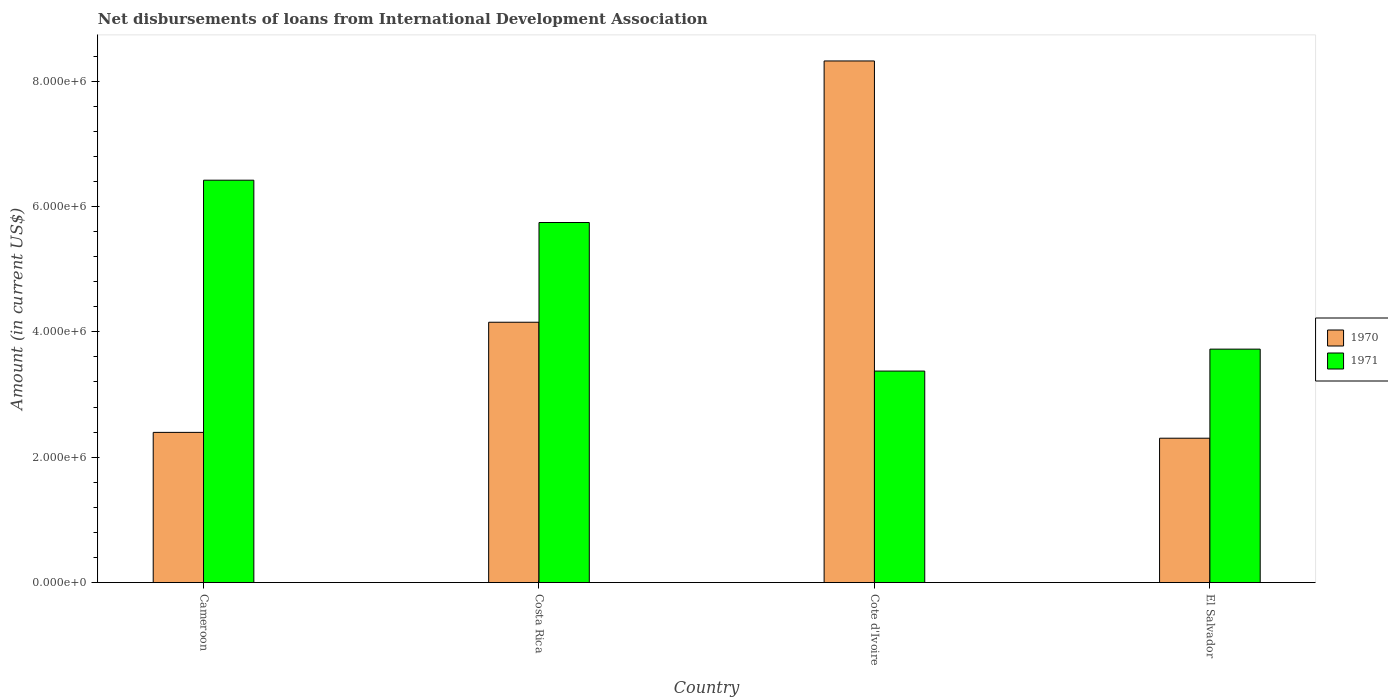How many different coloured bars are there?
Offer a very short reply. 2. How many groups of bars are there?
Provide a short and direct response. 4. Are the number of bars on each tick of the X-axis equal?
Provide a short and direct response. Yes. How many bars are there on the 4th tick from the left?
Your response must be concise. 2. What is the label of the 1st group of bars from the left?
Provide a short and direct response. Cameroon. What is the amount of loans disbursed in 1970 in Cote d'Ivoire?
Your answer should be very brief. 8.32e+06. Across all countries, what is the maximum amount of loans disbursed in 1970?
Offer a terse response. 8.32e+06. Across all countries, what is the minimum amount of loans disbursed in 1971?
Offer a very short reply. 3.37e+06. In which country was the amount of loans disbursed in 1970 maximum?
Provide a short and direct response. Cote d'Ivoire. In which country was the amount of loans disbursed in 1970 minimum?
Your response must be concise. El Salvador. What is the total amount of loans disbursed in 1970 in the graph?
Keep it short and to the point. 1.72e+07. What is the difference between the amount of loans disbursed in 1970 in Costa Rica and that in El Salvador?
Make the answer very short. 1.85e+06. What is the difference between the amount of loans disbursed in 1971 in El Salvador and the amount of loans disbursed in 1970 in Cameroon?
Your answer should be compact. 1.33e+06. What is the average amount of loans disbursed in 1971 per country?
Provide a short and direct response. 4.82e+06. What is the difference between the amount of loans disbursed of/in 1971 and amount of loans disbursed of/in 1970 in Cameroon?
Ensure brevity in your answer.  4.02e+06. In how many countries, is the amount of loans disbursed in 1970 greater than 4000000 US$?
Your answer should be very brief. 2. What is the ratio of the amount of loans disbursed in 1971 in Cameroon to that in El Salvador?
Provide a succinct answer. 1.72. Is the difference between the amount of loans disbursed in 1971 in Cameroon and El Salvador greater than the difference between the amount of loans disbursed in 1970 in Cameroon and El Salvador?
Ensure brevity in your answer.  Yes. What is the difference between the highest and the second highest amount of loans disbursed in 1971?
Your response must be concise. 2.70e+06. What is the difference between the highest and the lowest amount of loans disbursed in 1971?
Offer a very short reply. 3.04e+06. In how many countries, is the amount of loans disbursed in 1970 greater than the average amount of loans disbursed in 1970 taken over all countries?
Provide a succinct answer. 1. What does the 2nd bar from the left in Costa Rica represents?
Give a very brief answer. 1971. How many countries are there in the graph?
Keep it short and to the point. 4. What is the difference between two consecutive major ticks on the Y-axis?
Provide a short and direct response. 2.00e+06. Does the graph contain any zero values?
Offer a terse response. No. Does the graph contain grids?
Your answer should be compact. No. Where does the legend appear in the graph?
Keep it short and to the point. Center right. How many legend labels are there?
Give a very brief answer. 2. What is the title of the graph?
Make the answer very short. Net disbursements of loans from International Development Association. Does "1962" appear as one of the legend labels in the graph?
Provide a succinct answer. No. What is the label or title of the X-axis?
Your response must be concise. Country. What is the Amount (in current US$) in 1970 in Cameroon?
Provide a succinct answer. 2.40e+06. What is the Amount (in current US$) in 1971 in Cameroon?
Offer a very short reply. 6.42e+06. What is the Amount (in current US$) of 1970 in Costa Rica?
Offer a terse response. 4.15e+06. What is the Amount (in current US$) in 1971 in Costa Rica?
Offer a very short reply. 5.74e+06. What is the Amount (in current US$) in 1970 in Cote d'Ivoire?
Give a very brief answer. 8.32e+06. What is the Amount (in current US$) in 1971 in Cote d'Ivoire?
Ensure brevity in your answer.  3.37e+06. What is the Amount (in current US$) of 1970 in El Salvador?
Offer a terse response. 2.30e+06. What is the Amount (in current US$) of 1971 in El Salvador?
Offer a very short reply. 3.72e+06. Across all countries, what is the maximum Amount (in current US$) of 1970?
Offer a very short reply. 8.32e+06. Across all countries, what is the maximum Amount (in current US$) of 1971?
Your answer should be very brief. 6.42e+06. Across all countries, what is the minimum Amount (in current US$) in 1970?
Your answer should be very brief. 2.30e+06. Across all countries, what is the minimum Amount (in current US$) of 1971?
Make the answer very short. 3.37e+06. What is the total Amount (in current US$) in 1970 in the graph?
Make the answer very short. 1.72e+07. What is the total Amount (in current US$) of 1971 in the graph?
Provide a succinct answer. 1.93e+07. What is the difference between the Amount (in current US$) of 1970 in Cameroon and that in Costa Rica?
Provide a succinct answer. -1.76e+06. What is the difference between the Amount (in current US$) of 1971 in Cameroon and that in Costa Rica?
Give a very brief answer. 6.75e+05. What is the difference between the Amount (in current US$) of 1970 in Cameroon and that in Cote d'Ivoire?
Your response must be concise. -5.92e+06. What is the difference between the Amount (in current US$) in 1971 in Cameroon and that in Cote d'Ivoire?
Your answer should be very brief. 3.04e+06. What is the difference between the Amount (in current US$) of 1970 in Cameroon and that in El Salvador?
Make the answer very short. 9.30e+04. What is the difference between the Amount (in current US$) of 1971 in Cameroon and that in El Salvador?
Offer a very short reply. 2.70e+06. What is the difference between the Amount (in current US$) of 1970 in Costa Rica and that in Cote d'Ivoire?
Your answer should be compact. -4.17e+06. What is the difference between the Amount (in current US$) in 1971 in Costa Rica and that in Cote d'Ivoire?
Give a very brief answer. 2.37e+06. What is the difference between the Amount (in current US$) of 1970 in Costa Rica and that in El Salvador?
Make the answer very short. 1.85e+06. What is the difference between the Amount (in current US$) in 1971 in Costa Rica and that in El Salvador?
Your response must be concise. 2.02e+06. What is the difference between the Amount (in current US$) of 1970 in Cote d'Ivoire and that in El Salvador?
Provide a short and direct response. 6.02e+06. What is the difference between the Amount (in current US$) in 1971 in Cote d'Ivoire and that in El Salvador?
Your response must be concise. -3.50e+05. What is the difference between the Amount (in current US$) in 1970 in Cameroon and the Amount (in current US$) in 1971 in Costa Rica?
Provide a short and direct response. -3.35e+06. What is the difference between the Amount (in current US$) of 1970 in Cameroon and the Amount (in current US$) of 1971 in Cote d'Ivoire?
Give a very brief answer. -9.78e+05. What is the difference between the Amount (in current US$) of 1970 in Cameroon and the Amount (in current US$) of 1971 in El Salvador?
Give a very brief answer. -1.33e+06. What is the difference between the Amount (in current US$) in 1970 in Costa Rica and the Amount (in current US$) in 1971 in Cote d'Ivoire?
Make the answer very short. 7.79e+05. What is the difference between the Amount (in current US$) of 1970 in Costa Rica and the Amount (in current US$) of 1971 in El Salvador?
Give a very brief answer. 4.29e+05. What is the difference between the Amount (in current US$) in 1970 in Cote d'Ivoire and the Amount (in current US$) in 1971 in El Salvador?
Your answer should be very brief. 4.60e+06. What is the average Amount (in current US$) in 1970 per country?
Your answer should be very brief. 4.29e+06. What is the average Amount (in current US$) in 1971 per country?
Offer a terse response. 4.82e+06. What is the difference between the Amount (in current US$) in 1970 and Amount (in current US$) in 1971 in Cameroon?
Offer a very short reply. -4.02e+06. What is the difference between the Amount (in current US$) of 1970 and Amount (in current US$) of 1971 in Costa Rica?
Your response must be concise. -1.59e+06. What is the difference between the Amount (in current US$) of 1970 and Amount (in current US$) of 1971 in Cote d'Ivoire?
Provide a short and direct response. 4.95e+06. What is the difference between the Amount (in current US$) in 1970 and Amount (in current US$) in 1971 in El Salvador?
Give a very brief answer. -1.42e+06. What is the ratio of the Amount (in current US$) of 1970 in Cameroon to that in Costa Rica?
Your answer should be very brief. 0.58. What is the ratio of the Amount (in current US$) of 1971 in Cameroon to that in Costa Rica?
Offer a very short reply. 1.12. What is the ratio of the Amount (in current US$) of 1970 in Cameroon to that in Cote d'Ivoire?
Your answer should be very brief. 0.29. What is the ratio of the Amount (in current US$) in 1971 in Cameroon to that in Cote d'Ivoire?
Ensure brevity in your answer.  1.9. What is the ratio of the Amount (in current US$) of 1970 in Cameroon to that in El Salvador?
Give a very brief answer. 1.04. What is the ratio of the Amount (in current US$) of 1971 in Cameroon to that in El Salvador?
Give a very brief answer. 1.72. What is the ratio of the Amount (in current US$) in 1970 in Costa Rica to that in Cote d'Ivoire?
Your answer should be very brief. 0.5. What is the ratio of the Amount (in current US$) in 1971 in Costa Rica to that in Cote d'Ivoire?
Provide a succinct answer. 1.7. What is the ratio of the Amount (in current US$) in 1970 in Costa Rica to that in El Salvador?
Ensure brevity in your answer.  1.8. What is the ratio of the Amount (in current US$) in 1971 in Costa Rica to that in El Salvador?
Your answer should be very brief. 1.54. What is the ratio of the Amount (in current US$) of 1970 in Cote d'Ivoire to that in El Salvador?
Provide a succinct answer. 3.61. What is the ratio of the Amount (in current US$) of 1971 in Cote d'Ivoire to that in El Salvador?
Your answer should be very brief. 0.91. What is the difference between the highest and the second highest Amount (in current US$) of 1970?
Provide a short and direct response. 4.17e+06. What is the difference between the highest and the second highest Amount (in current US$) of 1971?
Make the answer very short. 6.75e+05. What is the difference between the highest and the lowest Amount (in current US$) of 1970?
Offer a terse response. 6.02e+06. What is the difference between the highest and the lowest Amount (in current US$) in 1971?
Keep it short and to the point. 3.04e+06. 